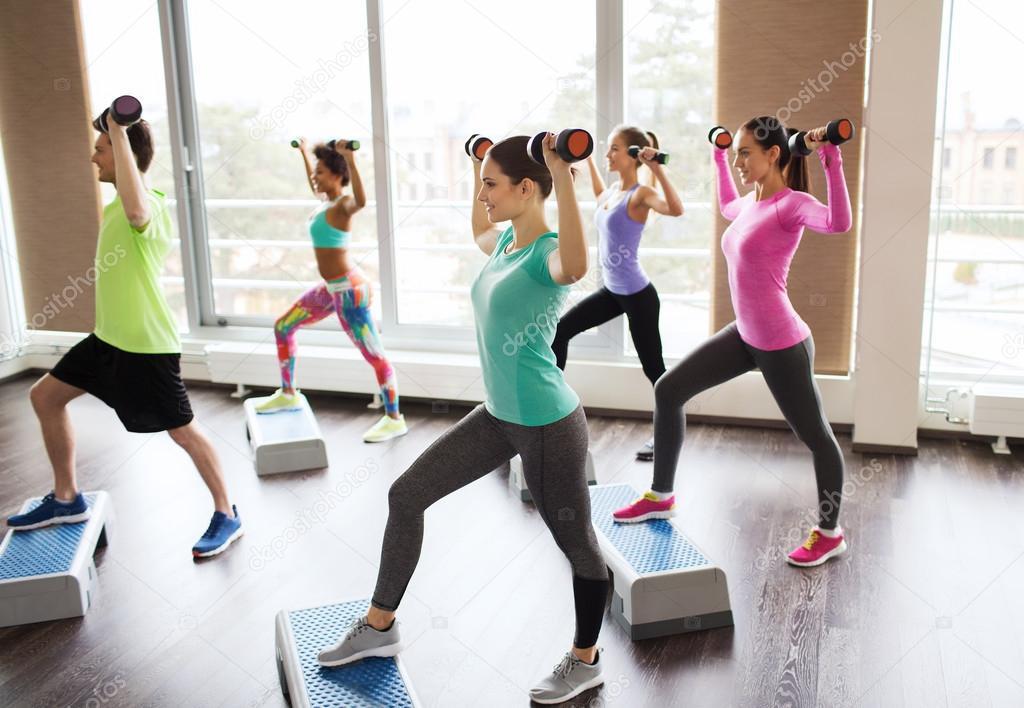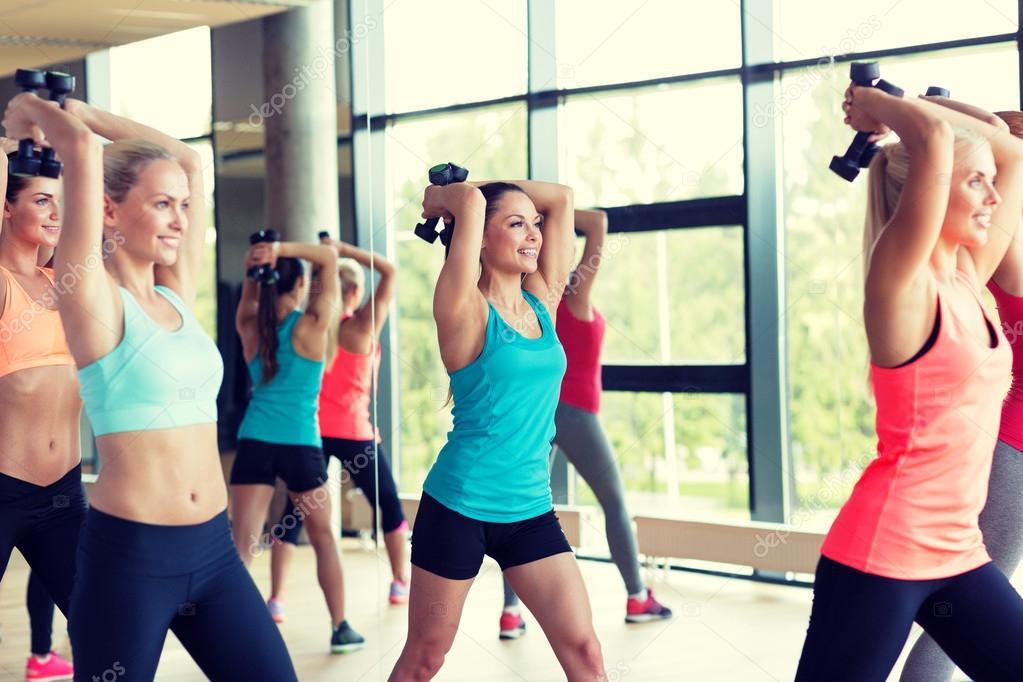The first image is the image on the left, the second image is the image on the right. For the images displayed, is the sentence "One image shows a workout with feet flat on the floor and hands holding dumbbells in front of the body, and the other image shows a similar workout with hands holding dumbbells out to the side." factually correct? Answer yes or no. No. The first image is the image on the left, the second image is the image on the right. Analyze the images presented: Is the assertion "At least five women are stepping on a workout step with one foot." valid? Answer yes or no. Yes. 